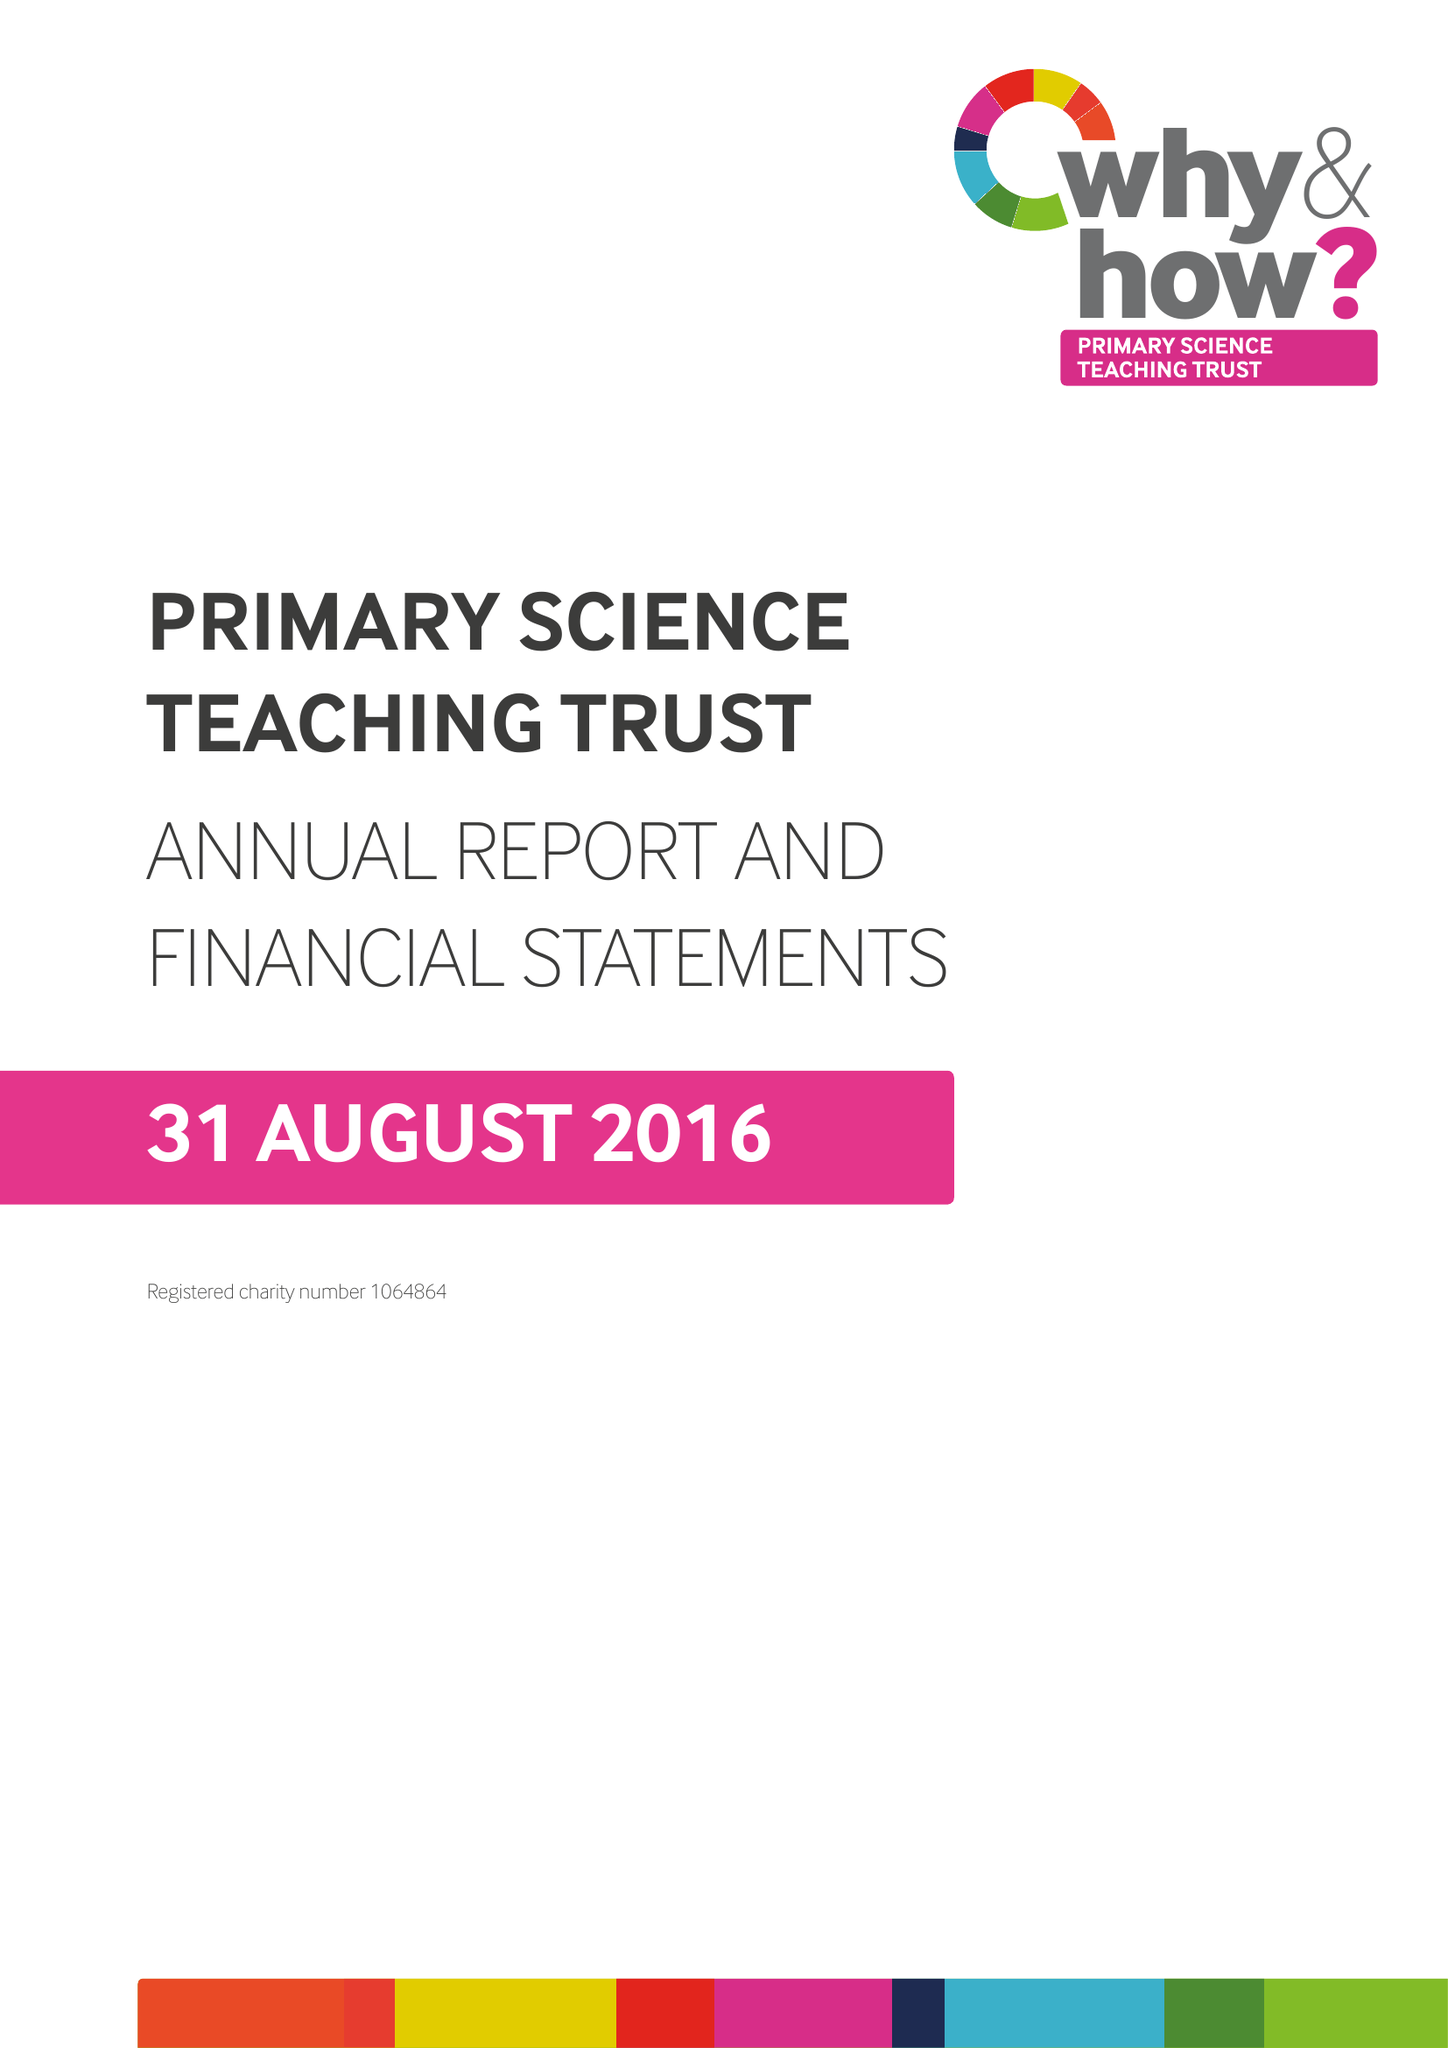What is the value for the spending_annually_in_british_pounds?
Answer the question using a single word or phrase. 1531953.00 